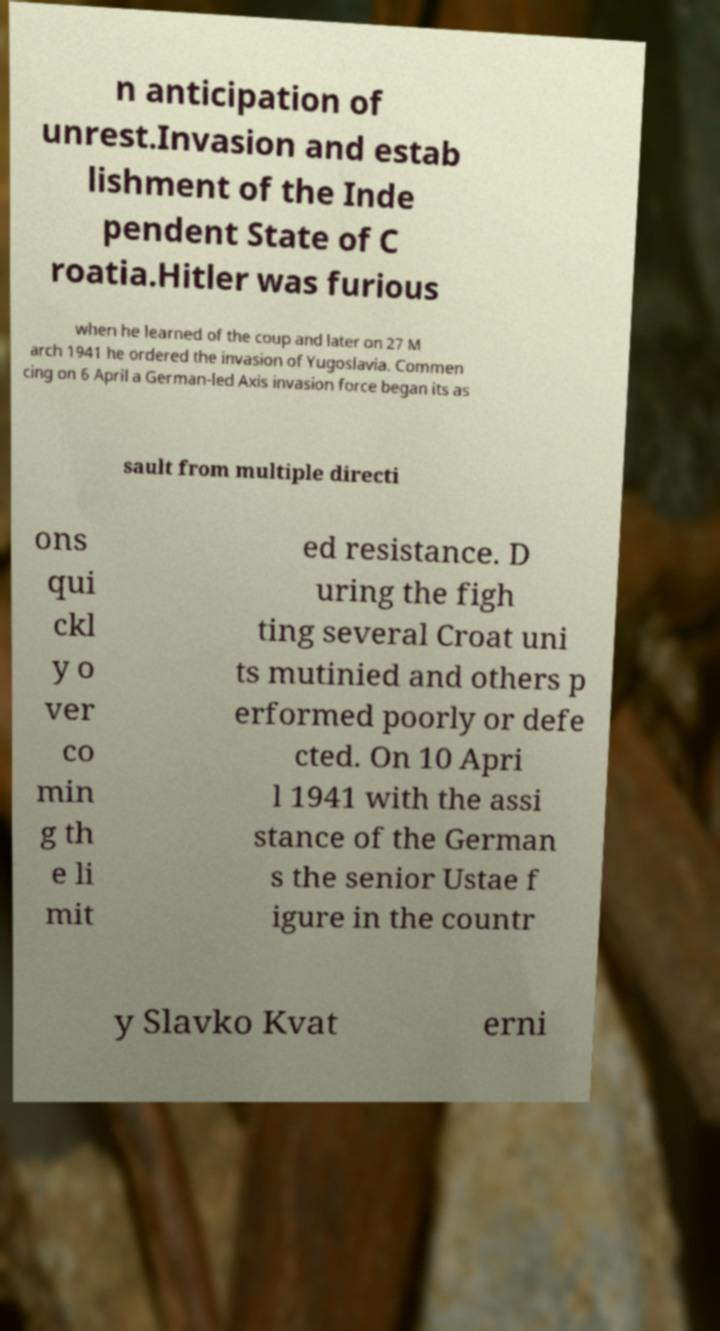Please read and relay the text visible in this image. What does it say? n anticipation of unrest.Invasion and estab lishment of the Inde pendent State of C roatia.Hitler was furious when he learned of the coup and later on 27 M arch 1941 he ordered the invasion of Yugoslavia. Commen cing on 6 April a German-led Axis invasion force began its as sault from multiple directi ons qui ckl y o ver co min g th e li mit ed resistance. D uring the figh ting several Croat uni ts mutinied and others p erformed poorly or defe cted. On 10 Apri l 1941 with the assi stance of the German s the senior Ustae f igure in the countr y Slavko Kvat erni 